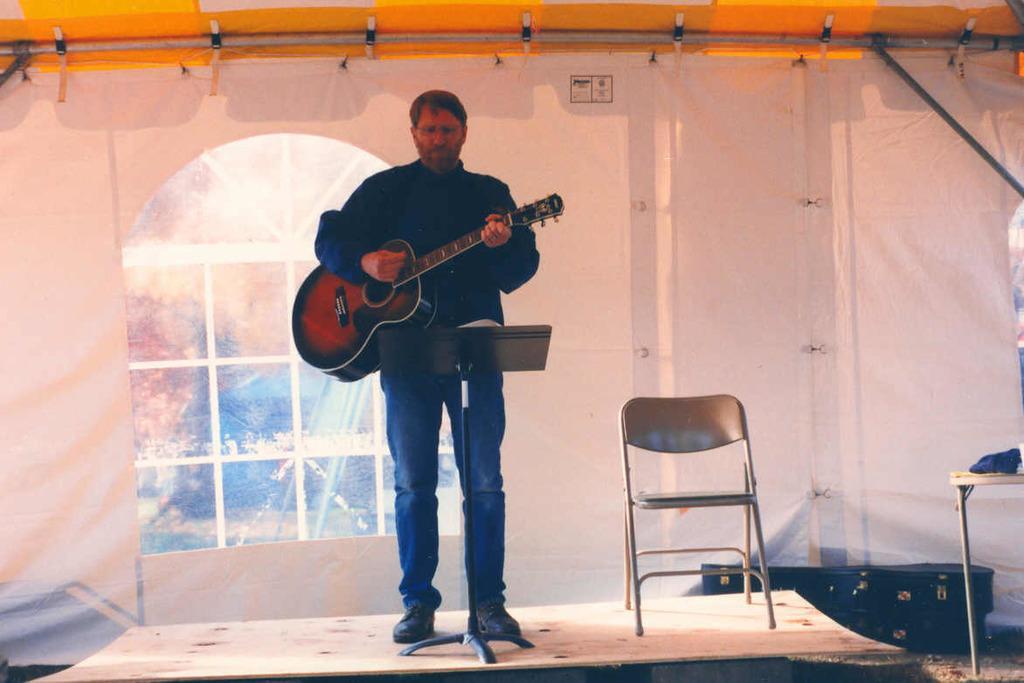Could you give a brief overview of what you see in this image? This man is standing and playing a guitar. This is a window. This is a chair on stage. This are guitar bags. 